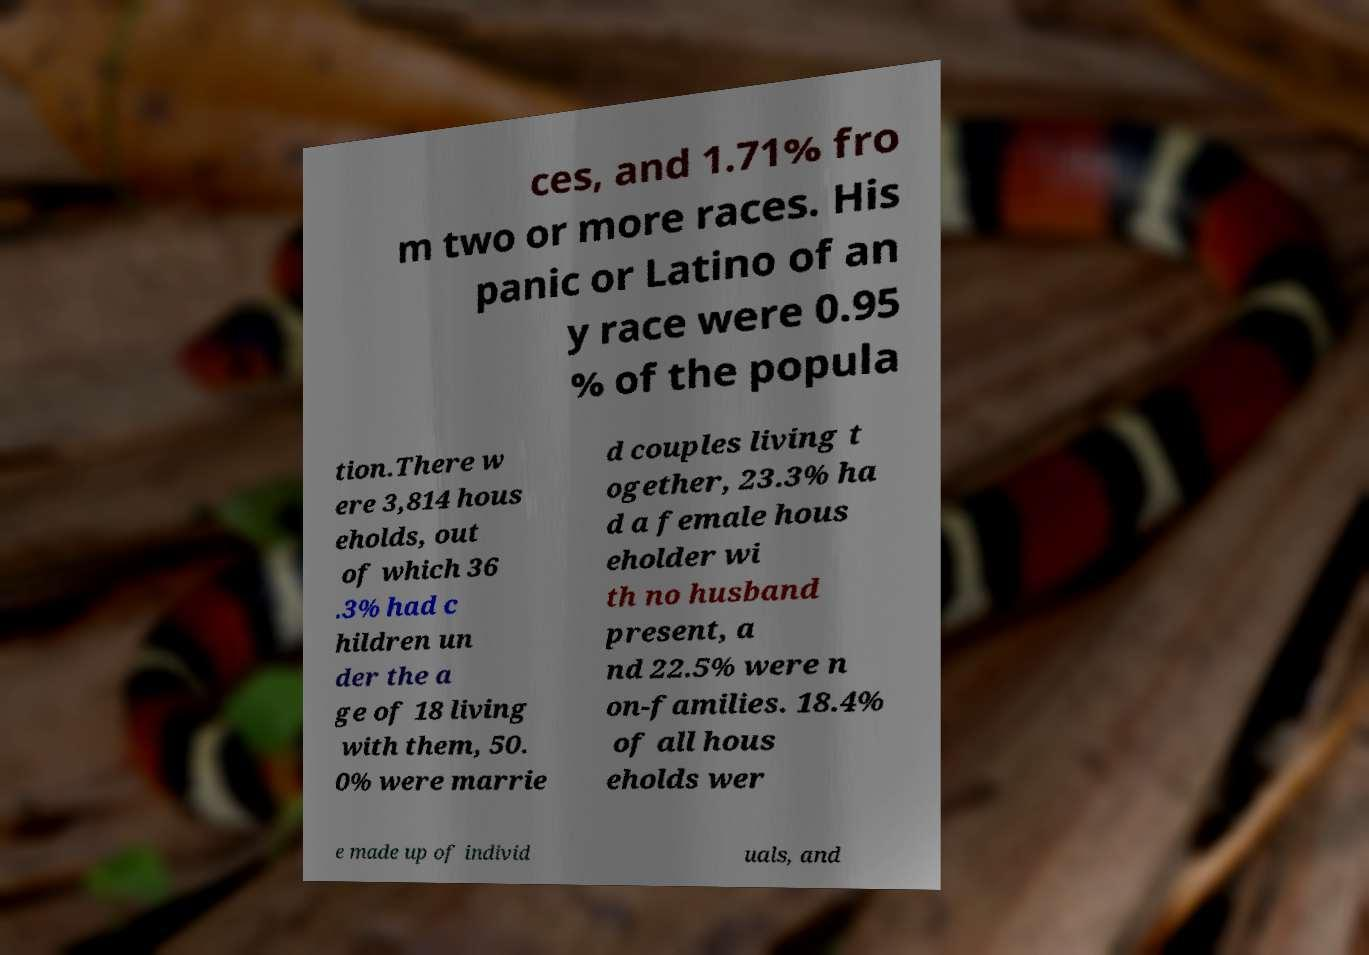Can you read and provide the text displayed in the image?This photo seems to have some interesting text. Can you extract and type it out for me? ces, and 1.71% fro m two or more races. His panic or Latino of an y race were 0.95 % of the popula tion.There w ere 3,814 hous eholds, out of which 36 .3% had c hildren un der the a ge of 18 living with them, 50. 0% were marrie d couples living t ogether, 23.3% ha d a female hous eholder wi th no husband present, a nd 22.5% were n on-families. 18.4% of all hous eholds wer e made up of individ uals, and 